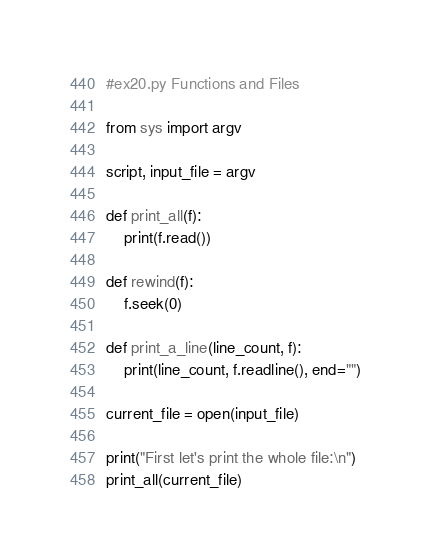Convert code to text. <code><loc_0><loc_0><loc_500><loc_500><_Python_>#ex20.py Functions and Files

from sys import argv

script, input_file = argv

def print_all(f):
	print(f.read())
	
def rewind(f):
	f.seek(0)

def print_a_line(line_count, f):
	print(line_count, f.readline(), end="")

current_file = open(input_file)

print("First let's print the whole file:\n")
print_all(current_file)
</code> 